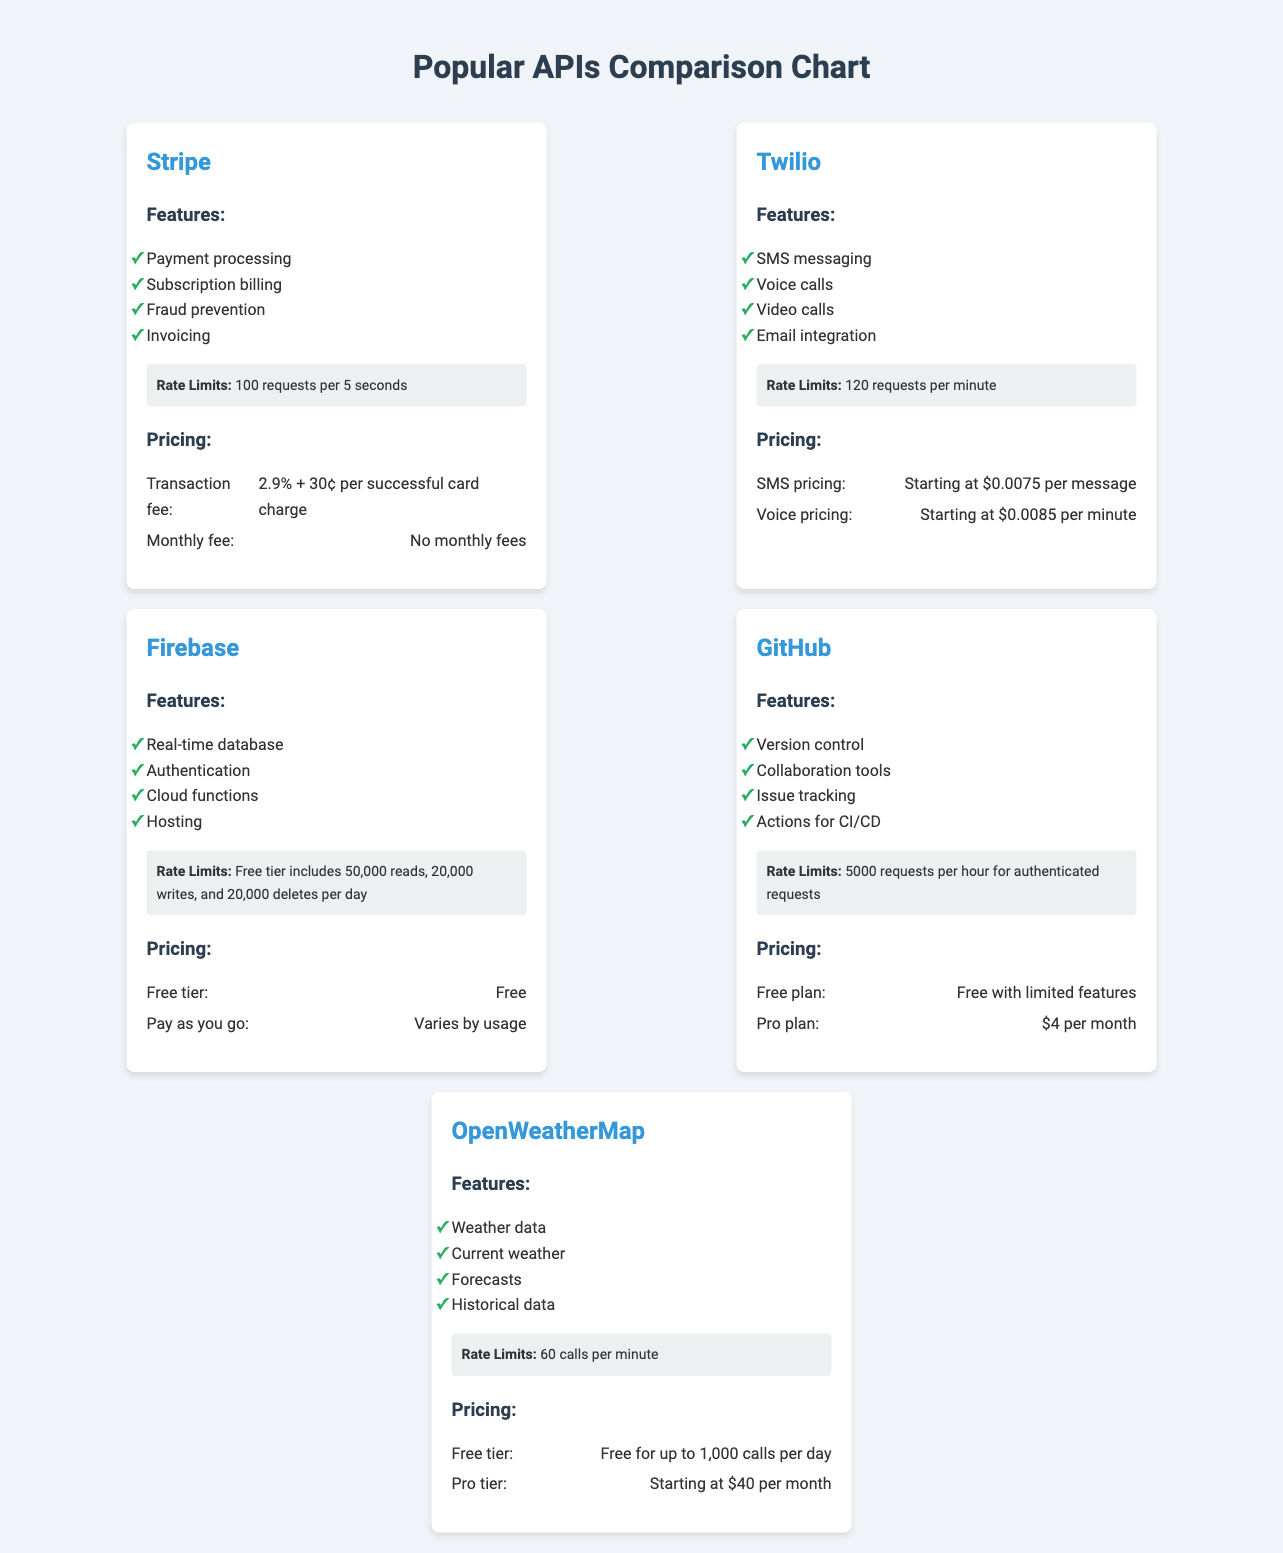What are the features of Stripe? The features of Stripe include payment processing, subscription billing, fraud prevention, and invoicing.
Answer: Payment processing, subscription billing, fraud prevention, invoicing What is Twilio's rate limit? Twilio has a rate limit of 120 requests per minute.
Answer: 120 requests per minute What is the price for the free tier of OpenWeatherMap? The free tier of OpenWeatherMap is free for up to 1,000 calls per day.
Answer: Free for up to 1,000 calls per day What pricing model does GitHub offer for its Pro plan? GitHub's Pro plan costs $4 per month.
Answer: $4 per month Which API has a feature for video calls? Twilio has a feature for video calls.
Answer: Twilio What is the transaction fee for Stripe? The transaction fee for Stripe is 2.9% + 30¢ per successful card charge.
Answer: 2.9% + 30¢ per successful card charge How many requests can you make to GitHub per hour for authenticated requests? You can make 5000 requests per hour for authenticated requests to GitHub.
Answer: 5000 requests per hour What type of data does Firebase provide? Firebase provides real-time database, authentication, cloud functions, and hosting.
Answer: Real-time database, authentication, cloud functions, hosting What is the starting price for SMS messaging with Twilio? The starting price for SMS messaging with Twilio is $0.0075 per message.
Answer: $0.0075 per message 